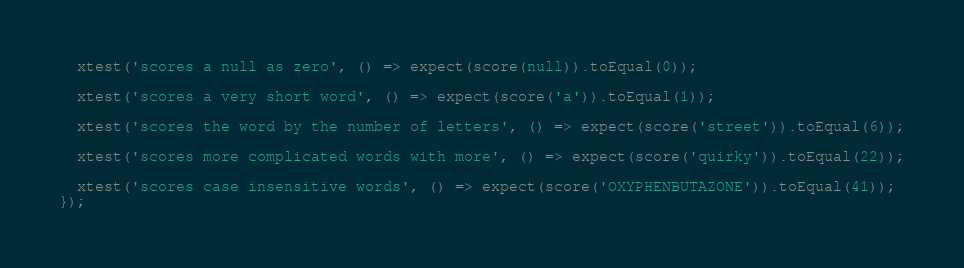<code> <loc_0><loc_0><loc_500><loc_500><_JavaScript_>  xtest('scores a null as zero', () => expect(score(null)).toEqual(0));

  xtest('scores a very short word', () => expect(score('a')).toEqual(1));

  xtest('scores the word by the number of letters', () => expect(score('street')).toEqual(6));

  xtest('scores more complicated words with more', () => expect(score('quirky')).toEqual(22));

  xtest('scores case insensitive words', () => expect(score('OXYPHENBUTAZONE')).toEqual(41));
});
</code> 